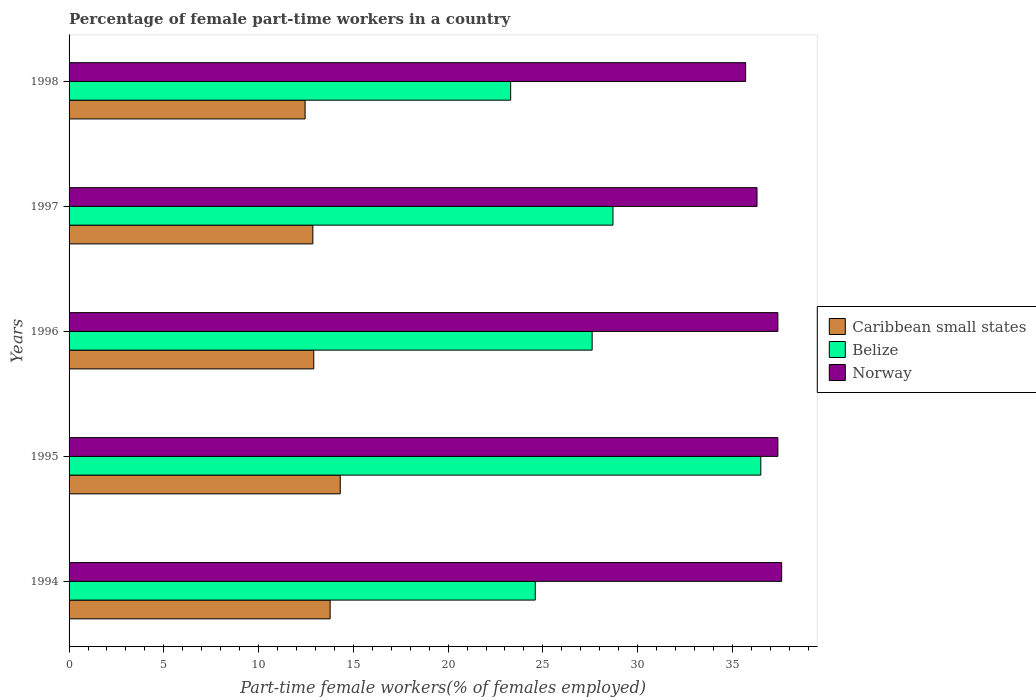How many different coloured bars are there?
Make the answer very short. 3. How many groups of bars are there?
Ensure brevity in your answer.  5. Are the number of bars per tick equal to the number of legend labels?
Provide a succinct answer. Yes. Are the number of bars on each tick of the Y-axis equal?
Ensure brevity in your answer.  Yes. What is the label of the 5th group of bars from the top?
Make the answer very short. 1994. What is the percentage of female part-time workers in Belize in 1997?
Offer a terse response. 28.7. Across all years, what is the maximum percentage of female part-time workers in Norway?
Make the answer very short. 37.6. Across all years, what is the minimum percentage of female part-time workers in Caribbean small states?
Make the answer very short. 12.45. In which year was the percentage of female part-time workers in Norway maximum?
Your response must be concise. 1994. In which year was the percentage of female part-time workers in Belize minimum?
Give a very brief answer. 1998. What is the total percentage of female part-time workers in Caribbean small states in the graph?
Ensure brevity in your answer.  66.31. What is the difference between the percentage of female part-time workers in Belize in 1994 and that in 1997?
Your answer should be very brief. -4.1. What is the difference between the percentage of female part-time workers in Belize in 1994 and the percentage of female part-time workers in Norway in 1998?
Give a very brief answer. -11.1. What is the average percentage of female part-time workers in Norway per year?
Provide a short and direct response. 36.88. In the year 1998, what is the difference between the percentage of female part-time workers in Belize and percentage of female part-time workers in Caribbean small states?
Make the answer very short. 10.85. In how many years, is the percentage of female part-time workers in Norway greater than 31 %?
Your answer should be compact. 5. What is the ratio of the percentage of female part-time workers in Belize in 1997 to that in 1998?
Offer a terse response. 1.23. What is the difference between the highest and the second highest percentage of female part-time workers in Norway?
Offer a terse response. 0.2. What is the difference between the highest and the lowest percentage of female part-time workers in Norway?
Provide a succinct answer. 1.9. Is the sum of the percentage of female part-time workers in Norway in 1996 and 1997 greater than the maximum percentage of female part-time workers in Belize across all years?
Your answer should be compact. Yes. What does the 3rd bar from the top in 1996 represents?
Your answer should be compact. Caribbean small states. What does the 3rd bar from the bottom in 1998 represents?
Your answer should be compact. Norway. Is it the case that in every year, the sum of the percentage of female part-time workers in Caribbean small states and percentage of female part-time workers in Belize is greater than the percentage of female part-time workers in Norway?
Your answer should be very brief. Yes. How many bars are there?
Your answer should be compact. 15. Are all the bars in the graph horizontal?
Keep it short and to the point. Yes. How many years are there in the graph?
Your response must be concise. 5. What is the difference between two consecutive major ticks on the X-axis?
Your answer should be very brief. 5. Are the values on the major ticks of X-axis written in scientific E-notation?
Make the answer very short. No. How are the legend labels stacked?
Provide a succinct answer. Vertical. What is the title of the graph?
Keep it short and to the point. Percentage of female part-time workers in a country. Does "Portugal" appear as one of the legend labels in the graph?
Provide a short and direct response. No. What is the label or title of the X-axis?
Your response must be concise. Part-time female workers(% of females employed). What is the Part-time female workers(% of females employed) of Caribbean small states in 1994?
Provide a succinct answer. 13.77. What is the Part-time female workers(% of females employed) of Belize in 1994?
Offer a terse response. 24.6. What is the Part-time female workers(% of females employed) of Norway in 1994?
Provide a short and direct response. 37.6. What is the Part-time female workers(% of females employed) of Caribbean small states in 1995?
Offer a very short reply. 14.31. What is the Part-time female workers(% of females employed) in Belize in 1995?
Make the answer very short. 36.5. What is the Part-time female workers(% of females employed) of Norway in 1995?
Offer a terse response. 37.4. What is the Part-time female workers(% of females employed) in Caribbean small states in 1996?
Make the answer very short. 12.91. What is the Part-time female workers(% of females employed) in Belize in 1996?
Provide a short and direct response. 27.6. What is the Part-time female workers(% of females employed) of Norway in 1996?
Offer a very short reply. 37.4. What is the Part-time female workers(% of females employed) in Caribbean small states in 1997?
Make the answer very short. 12.86. What is the Part-time female workers(% of females employed) in Belize in 1997?
Your answer should be compact. 28.7. What is the Part-time female workers(% of females employed) in Norway in 1997?
Your answer should be very brief. 36.3. What is the Part-time female workers(% of females employed) in Caribbean small states in 1998?
Your response must be concise. 12.45. What is the Part-time female workers(% of females employed) of Belize in 1998?
Your answer should be compact. 23.3. What is the Part-time female workers(% of females employed) of Norway in 1998?
Provide a succinct answer. 35.7. Across all years, what is the maximum Part-time female workers(% of females employed) of Caribbean small states?
Your answer should be very brief. 14.31. Across all years, what is the maximum Part-time female workers(% of females employed) of Belize?
Offer a terse response. 36.5. Across all years, what is the maximum Part-time female workers(% of females employed) of Norway?
Ensure brevity in your answer.  37.6. Across all years, what is the minimum Part-time female workers(% of females employed) in Caribbean small states?
Give a very brief answer. 12.45. Across all years, what is the minimum Part-time female workers(% of females employed) of Belize?
Offer a terse response. 23.3. Across all years, what is the minimum Part-time female workers(% of females employed) of Norway?
Make the answer very short. 35.7. What is the total Part-time female workers(% of females employed) of Caribbean small states in the graph?
Your response must be concise. 66.31. What is the total Part-time female workers(% of females employed) in Belize in the graph?
Make the answer very short. 140.7. What is the total Part-time female workers(% of females employed) in Norway in the graph?
Ensure brevity in your answer.  184.4. What is the difference between the Part-time female workers(% of females employed) in Caribbean small states in 1994 and that in 1995?
Offer a terse response. -0.53. What is the difference between the Part-time female workers(% of females employed) in Norway in 1994 and that in 1995?
Give a very brief answer. 0.2. What is the difference between the Part-time female workers(% of females employed) of Caribbean small states in 1994 and that in 1996?
Make the answer very short. 0.86. What is the difference between the Part-time female workers(% of females employed) of Norway in 1994 and that in 1996?
Provide a short and direct response. 0.2. What is the difference between the Part-time female workers(% of females employed) in Caribbean small states in 1994 and that in 1997?
Provide a succinct answer. 0.91. What is the difference between the Part-time female workers(% of females employed) in Belize in 1994 and that in 1997?
Give a very brief answer. -4.1. What is the difference between the Part-time female workers(% of females employed) in Norway in 1994 and that in 1997?
Provide a succinct answer. 1.3. What is the difference between the Part-time female workers(% of females employed) in Caribbean small states in 1994 and that in 1998?
Offer a terse response. 1.32. What is the difference between the Part-time female workers(% of females employed) of Belize in 1994 and that in 1998?
Provide a short and direct response. 1.3. What is the difference between the Part-time female workers(% of females employed) of Norway in 1994 and that in 1998?
Your answer should be very brief. 1.9. What is the difference between the Part-time female workers(% of females employed) of Caribbean small states in 1995 and that in 1996?
Ensure brevity in your answer.  1.4. What is the difference between the Part-time female workers(% of females employed) in Norway in 1995 and that in 1996?
Keep it short and to the point. 0. What is the difference between the Part-time female workers(% of females employed) in Caribbean small states in 1995 and that in 1997?
Make the answer very short. 1.45. What is the difference between the Part-time female workers(% of females employed) in Belize in 1995 and that in 1997?
Offer a very short reply. 7.8. What is the difference between the Part-time female workers(% of females employed) of Norway in 1995 and that in 1997?
Your answer should be compact. 1.1. What is the difference between the Part-time female workers(% of females employed) in Caribbean small states in 1995 and that in 1998?
Offer a very short reply. 1.85. What is the difference between the Part-time female workers(% of females employed) in Belize in 1995 and that in 1998?
Give a very brief answer. 13.2. What is the difference between the Part-time female workers(% of females employed) in Caribbean small states in 1996 and that in 1997?
Give a very brief answer. 0.05. What is the difference between the Part-time female workers(% of females employed) in Belize in 1996 and that in 1997?
Provide a succinct answer. -1.1. What is the difference between the Part-time female workers(% of females employed) of Norway in 1996 and that in 1997?
Provide a succinct answer. 1.1. What is the difference between the Part-time female workers(% of females employed) in Caribbean small states in 1996 and that in 1998?
Your answer should be very brief. 0.46. What is the difference between the Part-time female workers(% of females employed) of Norway in 1996 and that in 1998?
Offer a very short reply. 1.7. What is the difference between the Part-time female workers(% of females employed) in Caribbean small states in 1997 and that in 1998?
Make the answer very short. 0.41. What is the difference between the Part-time female workers(% of females employed) in Caribbean small states in 1994 and the Part-time female workers(% of females employed) in Belize in 1995?
Offer a terse response. -22.73. What is the difference between the Part-time female workers(% of females employed) in Caribbean small states in 1994 and the Part-time female workers(% of females employed) in Norway in 1995?
Your answer should be very brief. -23.63. What is the difference between the Part-time female workers(% of females employed) of Belize in 1994 and the Part-time female workers(% of females employed) of Norway in 1995?
Give a very brief answer. -12.8. What is the difference between the Part-time female workers(% of females employed) of Caribbean small states in 1994 and the Part-time female workers(% of females employed) of Belize in 1996?
Your answer should be compact. -13.83. What is the difference between the Part-time female workers(% of females employed) in Caribbean small states in 1994 and the Part-time female workers(% of females employed) in Norway in 1996?
Provide a succinct answer. -23.63. What is the difference between the Part-time female workers(% of females employed) in Caribbean small states in 1994 and the Part-time female workers(% of females employed) in Belize in 1997?
Offer a terse response. -14.93. What is the difference between the Part-time female workers(% of females employed) of Caribbean small states in 1994 and the Part-time female workers(% of females employed) of Norway in 1997?
Offer a terse response. -22.53. What is the difference between the Part-time female workers(% of females employed) of Belize in 1994 and the Part-time female workers(% of females employed) of Norway in 1997?
Make the answer very short. -11.7. What is the difference between the Part-time female workers(% of females employed) of Caribbean small states in 1994 and the Part-time female workers(% of females employed) of Belize in 1998?
Offer a very short reply. -9.53. What is the difference between the Part-time female workers(% of females employed) of Caribbean small states in 1994 and the Part-time female workers(% of females employed) of Norway in 1998?
Offer a terse response. -21.93. What is the difference between the Part-time female workers(% of females employed) of Caribbean small states in 1995 and the Part-time female workers(% of females employed) of Belize in 1996?
Offer a very short reply. -13.29. What is the difference between the Part-time female workers(% of females employed) in Caribbean small states in 1995 and the Part-time female workers(% of females employed) in Norway in 1996?
Keep it short and to the point. -23.09. What is the difference between the Part-time female workers(% of females employed) of Belize in 1995 and the Part-time female workers(% of females employed) of Norway in 1996?
Keep it short and to the point. -0.9. What is the difference between the Part-time female workers(% of females employed) of Caribbean small states in 1995 and the Part-time female workers(% of females employed) of Belize in 1997?
Your answer should be very brief. -14.39. What is the difference between the Part-time female workers(% of females employed) of Caribbean small states in 1995 and the Part-time female workers(% of females employed) of Norway in 1997?
Provide a succinct answer. -21.99. What is the difference between the Part-time female workers(% of females employed) in Caribbean small states in 1995 and the Part-time female workers(% of females employed) in Belize in 1998?
Keep it short and to the point. -8.99. What is the difference between the Part-time female workers(% of females employed) of Caribbean small states in 1995 and the Part-time female workers(% of females employed) of Norway in 1998?
Offer a terse response. -21.39. What is the difference between the Part-time female workers(% of females employed) in Belize in 1995 and the Part-time female workers(% of females employed) in Norway in 1998?
Provide a succinct answer. 0.8. What is the difference between the Part-time female workers(% of females employed) in Caribbean small states in 1996 and the Part-time female workers(% of females employed) in Belize in 1997?
Provide a short and direct response. -15.79. What is the difference between the Part-time female workers(% of females employed) in Caribbean small states in 1996 and the Part-time female workers(% of females employed) in Norway in 1997?
Keep it short and to the point. -23.39. What is the difference between the Part-time female workers(% of females employed) of Caribbean small states in 1996 and the Part-time female workers(% of females employed) of Belize in 1998?
Offer a very short reply. -10.39. What is the difference between the Part-time female workers(% of females employed) of Caribbean small states in 1996 and the Part-time female workers(% of females employed) of Norway in 1998?
Your response must be concise. -22.79. What is the difference between the Part-time female workers(% of females employed) in Caribbean small states in 1997 and the Part-time female workers(% of females employed) in Belize in 1998?
Offer a terse response. -10.44. What is the difference between the Part-time female workers(% of females employed) in Caribbean small states in 1997 and the Part-time female workers(% of females employed) in Norway in 1998?
Provide a short and direct response. -22.84. What is the difference between the Part-time female workers(% of females employed) in Belize in 1997 and the Part-time female workers(% of females employed) in Norway in 1998?
Your response must be concise. -7. What is the average Part-time female workers(% of females employed) in Caribbean small states per year?
Offer a very short reply. 13.26. What is the average Part-time female workers(% of females employed) in Belize per year?
Offer a terse response. 28.14. What is the average Part-time female workers(% of females employed) in Norway per year?
Give a very brief answer. 36.88. In the year 1994, what is the difference between the Part-time female workers(% of females employed) of Caribbean small states and Part-time female workers(% of females employed) of Belize?
Make the answer very short. -10.83. In the year 1994, what is the difference between the Part-time female workers(% of females employed) of Caribbean small states and Part-time female workers(% of females employed) of Norway?
Your answer should be very brief. -23.83. In the year 1995, what is the difference between the Part-time female workers(% of females employed) of Caribbean small states and Part-time female workers(% of females employed) of Belize?
Keep it short and to the point. -22.19. In the year 1995, what is the difference between the Part-time female workers(% of females employed) in Caribbean small states and Part-time female workers(% of females employed) in Norway?
Provide a succinct answer. -23.09. In the year 1995, what is the difference between the Part-time female workers(% of females employed) in Belize and Part-time female workers(% of females employed) in Norway?
Offer a very short reply. -0.9. In the year 1996, what is the difference between the Part-time female workers(% of females employed) of Caribbean small states and Part-time female workers(% of females employed) of Belize?
Provide a short and direct response. -14.69. In the year 1996, what is the difference between the Part-time female workers(% of females employed) in Caribbean small states and Part-time female workers(% of females employed) in Norway?
Provide a short and direct response. -24.49. In the year 1997, what is the difference between the Part-time female workers(% of females employed) of Caribbean small states and Part-time female workers(% of females employed) of Belize?
Offer a terse response. -15.84. In the year 1997, what is the difference between the Part-time female workers(% of females employed) of Caribbean small states and Part-time female workers(% of females employed) of Norway?
Ensure brevity in your answer.  -23.44. In the year 1997, what is the difference between the Part-time female workers(% of females employed) in Belize and Part-time female workers(% of females employed) in Norway?
Your answer should be compact. -7.6. In the year 1998, what is the difference between the Part-time female workers(% of females employed) of Caribbean small states and Part-time female workers(% of females employed) of Belize?
Provide a succinct answer. -10.85. In the year 1998, what is the difference between the Part-time female workers(% of females employed) of Caribbean small states and Part-time female workers(% of females employed) of Norway?
Offer a terse response. -23.25. In the year 1998, what is the difference between the Part-time female workers(% of females employed) in Belize and Part-time female workers(% of females employed) in Norway?
Offer a terse response. -12.4. What is the ratio of the Part-time female workers(% of females employed) in Caribbean small states in 1994 to that in 1995?
Keep it short and to the point. 0.96. What is the ratio of the Part-time female workers(% of females employed) of Belize in 1994 to that in 1995?
Ensure brevity in your answer.  0.67. What is the ratio of the Part-time female workers(% of females employed) of Norway in 1994 to that in 1995?
Provide a succinct answer. 1.01. What is the ratio of the Part-time female workers(% of females employed) in Caribbean small states in 1994 to that in 1996?
Offer a very short reply. 1.07. What is the ratio of the Part-time female workers(% of females employed) of Belize in 1994 to that in 1996?
Make the answer very short. 0.89. What is the ratio of the Part-time female workers(% of females employed) in Caribbean small states in 1994 to that in 1997?
Your answer should be very brief. 1.07. What is the ratio of the Part-time female workers(% of females employed) of Norway in 1994 to that in 1997?
Offer a very short reply. 1.04. What is the ratio of the Part-time female workers(% of females employed) in Caribbean small states in 1994 to that in 1998?
Give a very brief answer. 1.11. What is the ratio of the Part-time female workers(% of females employed) in Belize in 1994 to that in 1998?
Your response must be concise. 1.06. What is the ratio of the Part-time female workers(% of females employed) of Norway in 1994 to that in 1998?
Your answer should be very brief. 1.05. What is the ratio of the Part-time female workers(% of females employed) of Caribbean small states in 1995 to that in 1996?
Offer a terse response. 1.11. What is the ratio of the Part-time female workers(% of females employed) in Belize in 1995 to that in 1996?
Provide a succinct answer. 1.32. What is the ratio of the Part-time female workers(% of females employed) in Caribbean small states in 1995 to that in 1997?
Your answer should be compact. 1.11. What is the ratio of the Part-time female workers(% of females employed) in Belize in 1995 to that in 1997?
Ensure brevity in your answer.  1.27. What is the ratio of the Part-time female workers(% of females employed) in Norway in 1995 to that in 1997?
Keep it short and to the point. 1.03. What is the ratio of the Part-time female workers(% of females employed) in Caribbean small states in 1995 to that in 1998?
Ensure brevity in your answer.  1.15. What is the ratio of the Part-time female workers(% of females employed) in Belize in 1995 to that in 1998?
Ensure brevity in your answer.  1.57. What is the ratio of the Part-time female workers(% of females employed) in Norway in 1995 to that in 1998?
Ensure brevity in your answer.  1.05. What is the ratio of the Part-time female workers(% of females employed) in Belize in 1996 to that in 1997?
Offer a terse response. 0.96. What is the ratio of the Part-time female workers(% of females employed) of Norway in 1996 to that in 1997?
Provide a succinct answer. 1.03. What is the ratio of the Part-time female workers(% of females employed) of Caribbean small states in 1996 to that in 1998?
Ensure brevity in your answer.  1.04. What is the ratio of the Part-time female workers(% of females employed) in Belize in 1996 to that in 1998?
Your answer should be very brief. 1.18. What is the ratio of the Part-time female workers(% of females employed) of Norway in 1996 to that in 1998?
Offer a very short reply. 1.05. What is the ratio of the Part-time female workers(% of females employed) in Caribbean small states in 1997 to that in 1998?
Give a very brief answer. 1.03. What is the ratio of the Part-time female workers(% of females employed) of Belize in 1997 to that in 1998?
Your answer should be compact. 1.23. What is the ratio of the Part-time female workers(% of females employed) in Norway in 1997 to that in 1998?
Provide a succinct answer. 1.02. What is the difference between the highest and the second highest Part-time female workers(% of females employed) of Caribbean small states?
Provide a short and direct response. 0.53. What is the difference between the highest and the lowest Part-time female workers(% of females employed) in Caribbean small states?
Give a very brief answer. 1.85. What is the difference between the highest and the lowest Part-time female workers(% of females employed) of Belize?
Make the answer very short. 13.2. 